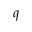Convert formula to latex. <formula><loc_0><loc_0><loc_500><loc_500>q</formula> 